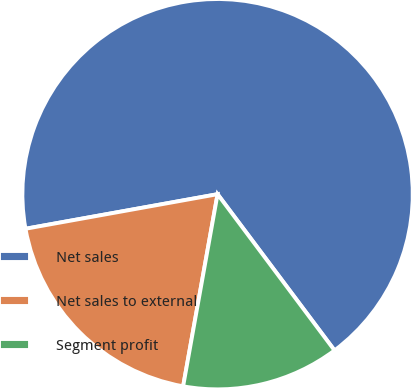Convert chart. <chart><loc_0><loc_0><loc_500><loc_500><pie_chart><fcel>Net sales<fcel>Net sales to external<fcel>Segment profit<nl><fcel>67.6%<fcel>19.34%<fcel>13.05%<nl></chart> 